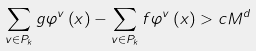Convert formula to latex. <formula><loc_0><loc_0><loc_500><loc_500>\sum _ { v \in P _ { k } } g \varphi ^ { v } \left ( x \right ) - \sum _ { v \in P _ { k } } f \varphi ^ { v } \left ( x \right ) > c M ^ { d }</formula> 